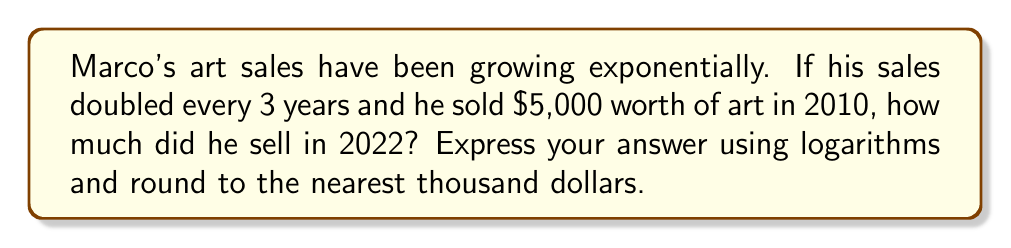Could you help me with this problem? Let's approach this step-by-step:

1) First, we need to determine how many 3-year periods passed between 2010 and 2022:
   $$(2022 - 2010) \div 3 = 12 \div 3 = 4$$

2) Now, we can set up our exponential growth equation:
   $$A = 5000 \cdot 2^4$$
   Where $A$ is the amount sold in 2022, $5000 is the initial amount, and $2^4$ represents doubling 4 times.

3) To solve this using logarithms, we can take the log of both sides:
   $$\log A = \log(5000 \cdot 2^4)$$

4) Using the logarithm product rule:
   $$\log A = \log 5000 + \log 2^4$$

5) Simplify the right side:
   $$\log A = \log 5000 + 4\log 2$$

6) Now we can calculate:
   $$\log A \approx 3.6990 + 4(0.3010) \approx 4.9030$$

7) To get $A$, we take the antilog (10 to the power) of both sides:
   $$A = 10^{4.9030} \approx 80,000$$

8) Rounding to the nearest thousand:
   $$A \approx 80,000$$

Therefore, Marco sold approximately $80,000 worth of art in 2022.
Answer: $80,000 